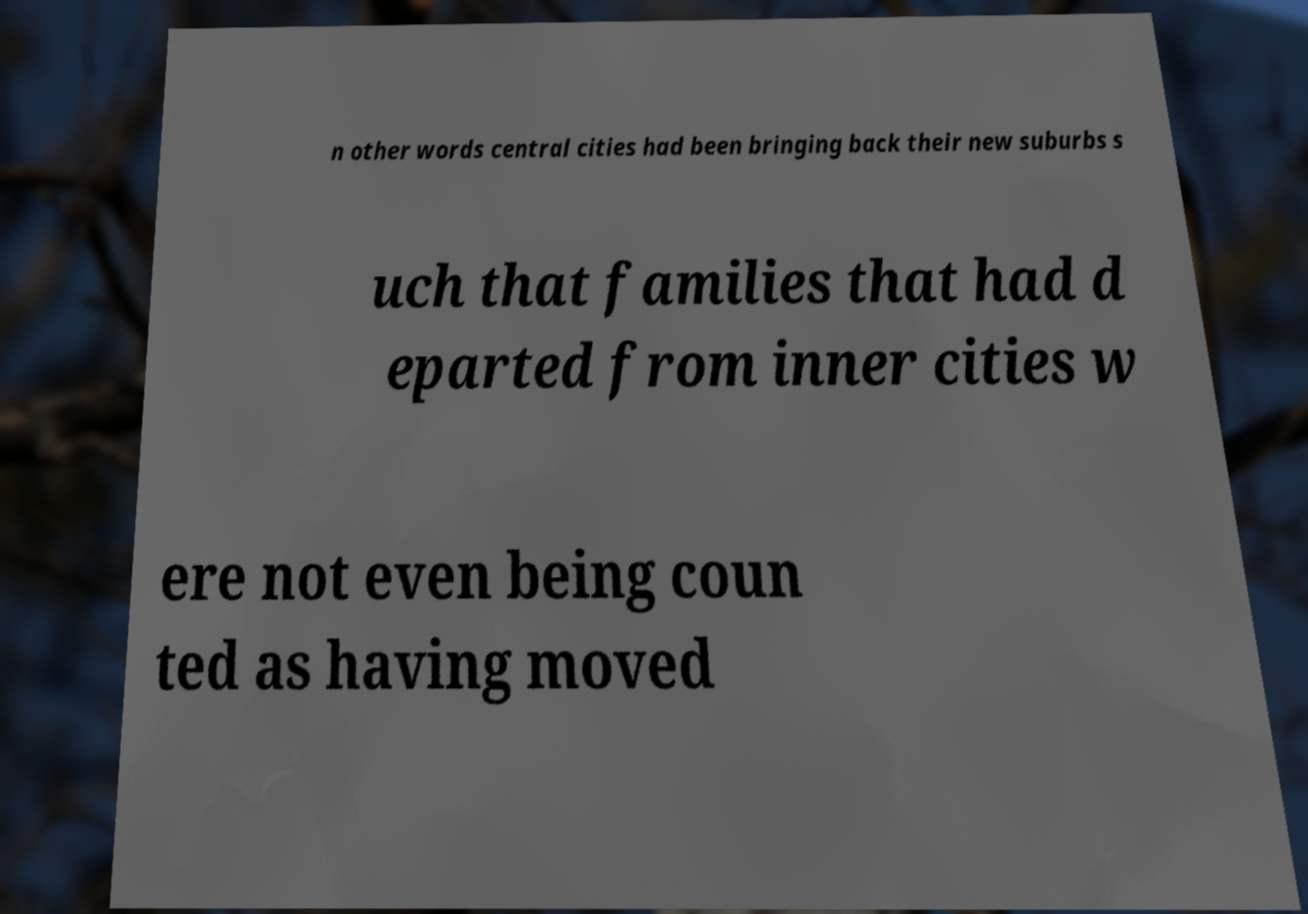Could you extract and type out the text from this image? n other words central cities had been bringing back their new suburbs s uch that families that had d eparted from inner cities w ere not even being coun ted as having moved 